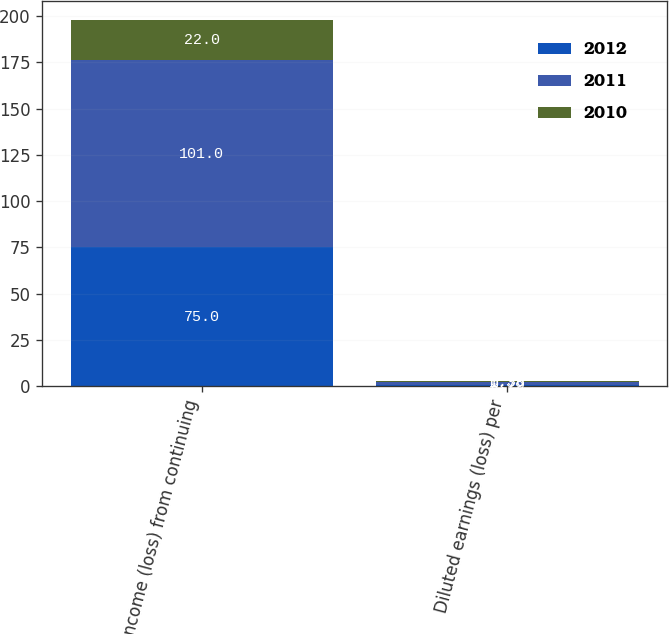<chart> <loc_0><loc_0><loc_500><loc_500><stacked_bar_chart><ecel><fcel>Income (loss) from continuing<fcel>Diluted earnings (loss) per<nl><fcel>2012<fcel>75<fcel>0.79<nl><fcel>2011<fcel>101<fcel>1.38<nl><fcel>2010<fcel>22<fcel>0.38<nl></chart> 